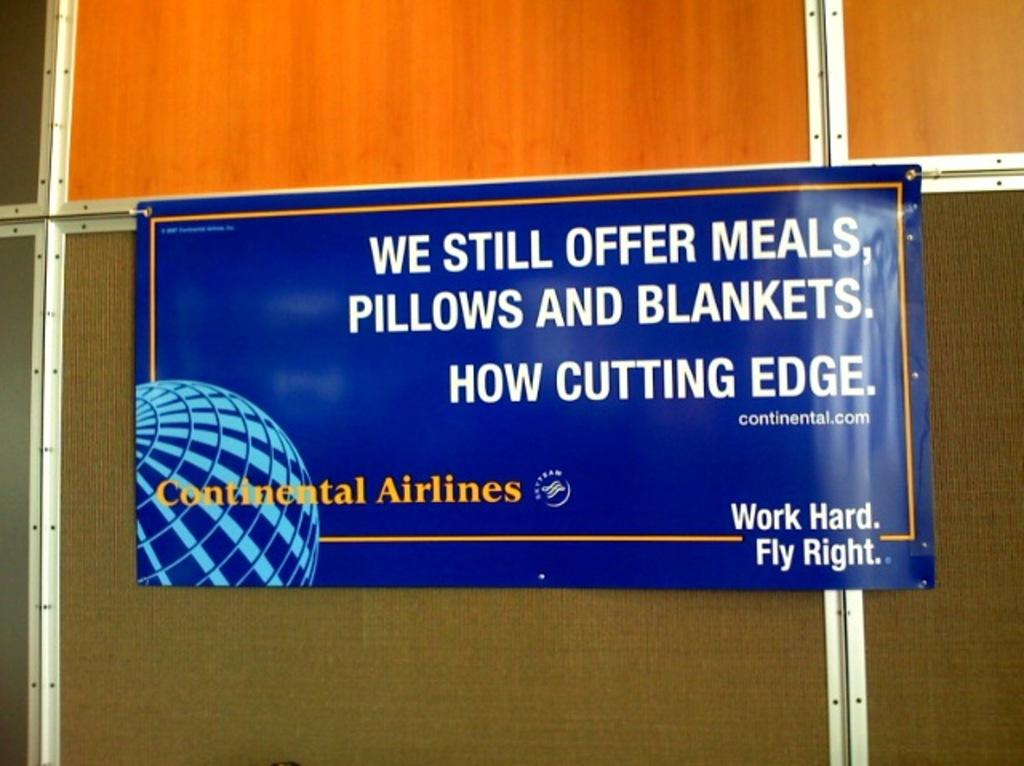<image>
Present a compact description of the photo's key features. An ad for Continental Airlines advertises meals, pillows, and blankets. 